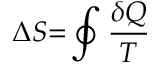<formula> <loc_0><loc_0><loc_500><loc_500>\Delta S { = } \oint { \frac { \delta Q } { T } }</formula> 